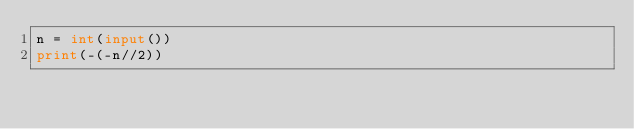<code> <loc_0><loc_0><loc_500><loc_500><_Python_>n = int(input())
print(-(-n//2))</code> 